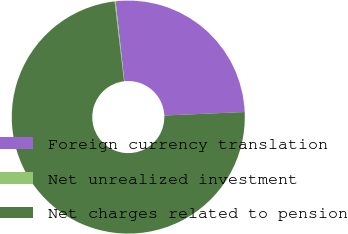Convert chart. <chart><loc_0><loc_0><loc_500><loc_500><pie_chart><fcel>Foreign currency translation<fcel>Net unrealized investment<fcel>Net charges related to pension<nl><fcel>26.04%<fcel>0.14%<fcel>73.82%<nl></chart> 